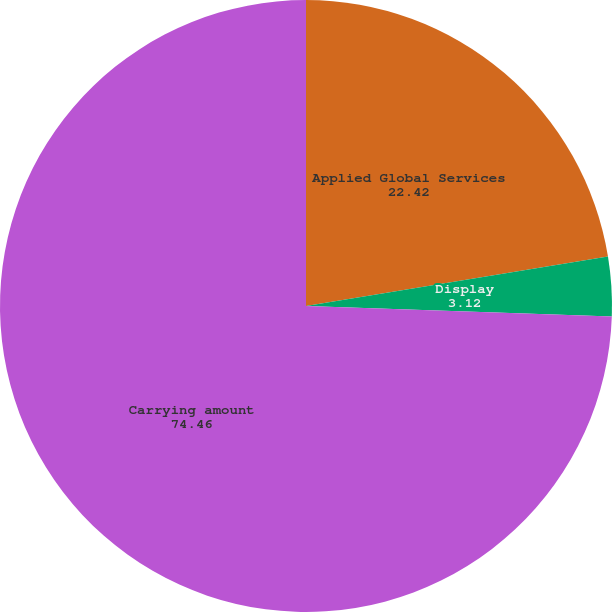Convert chart to OTSL. <chart><loc_0><loc_0><loc_500><loc_500><pie_chart><fcel>Applied Global Services<fcel>Display<fcel>Carrying amount<nl><fcel>22.42%<fcel>3.12%<fcel>74.46%<nl></chart> 